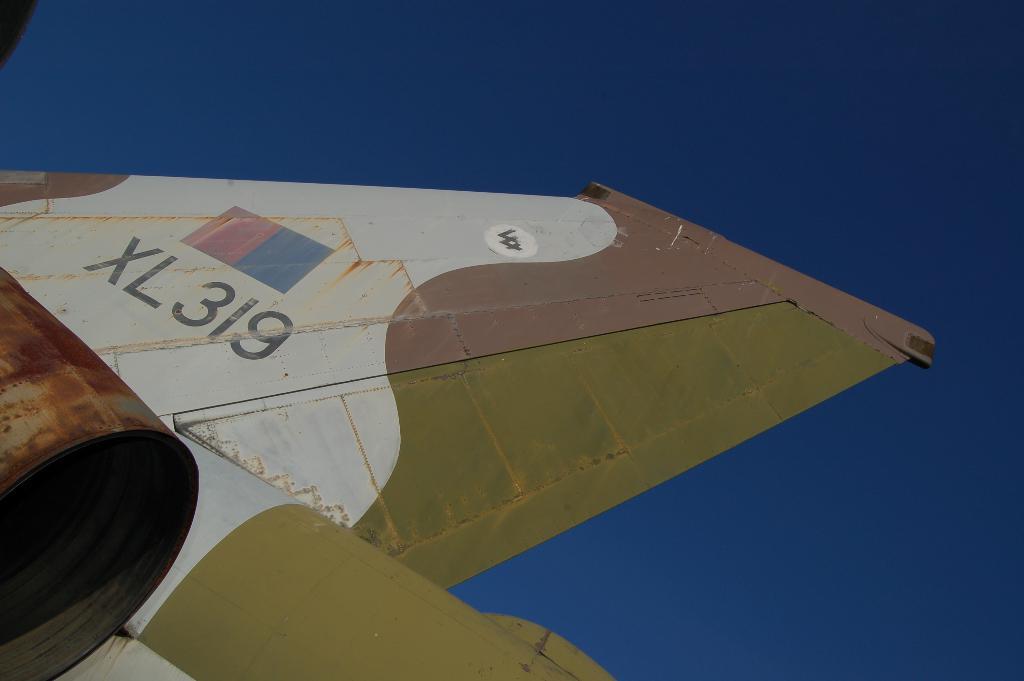What is this planes id number?
Your answer should be compact. Xl319. 